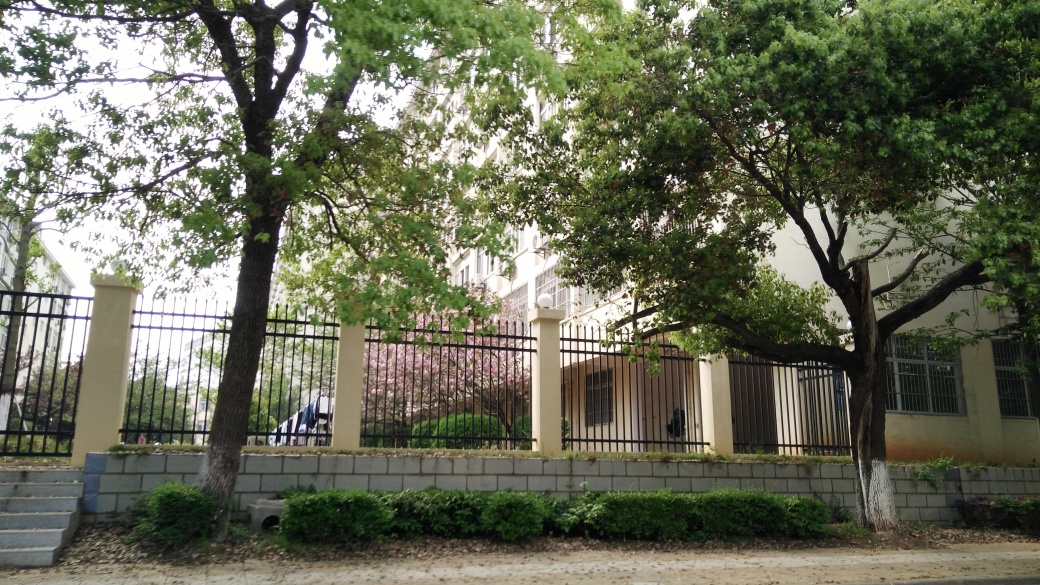How is the background in the image?
A. Slightly blurry
B. Sharp and focused
C. Clear
D. Out of focus The background in the image is primarily clear, with buildings and trees that are discernible, though not sharp. This indicates some level of focus, but not to the extent that every detail is crisp. Therefore, while option 'B. Sharp and focused' is not entirely accurate, neither is 'D. Out of focus', making option 'C. Clear' the closest to an accurate description. However, a minutely more concise term might be 'slightly blurry', which would suggest a minor lack of sharpness while still being mostly clear. 